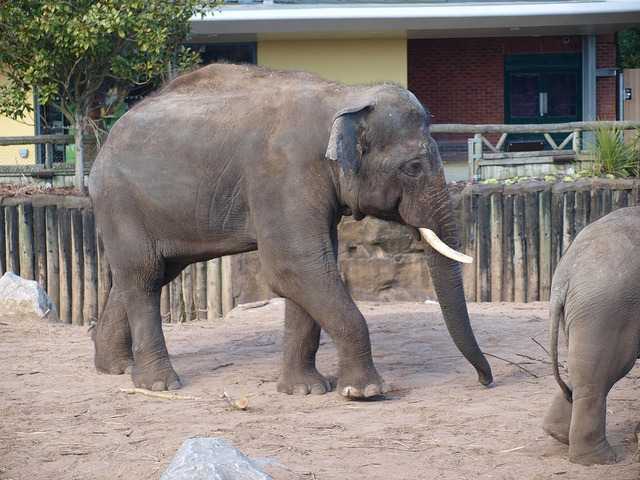Describe the objects in this image and their specific colors. I can see elephant in gray, darkgray, and black tones and elephant in gray and darkgray tones in this image. 